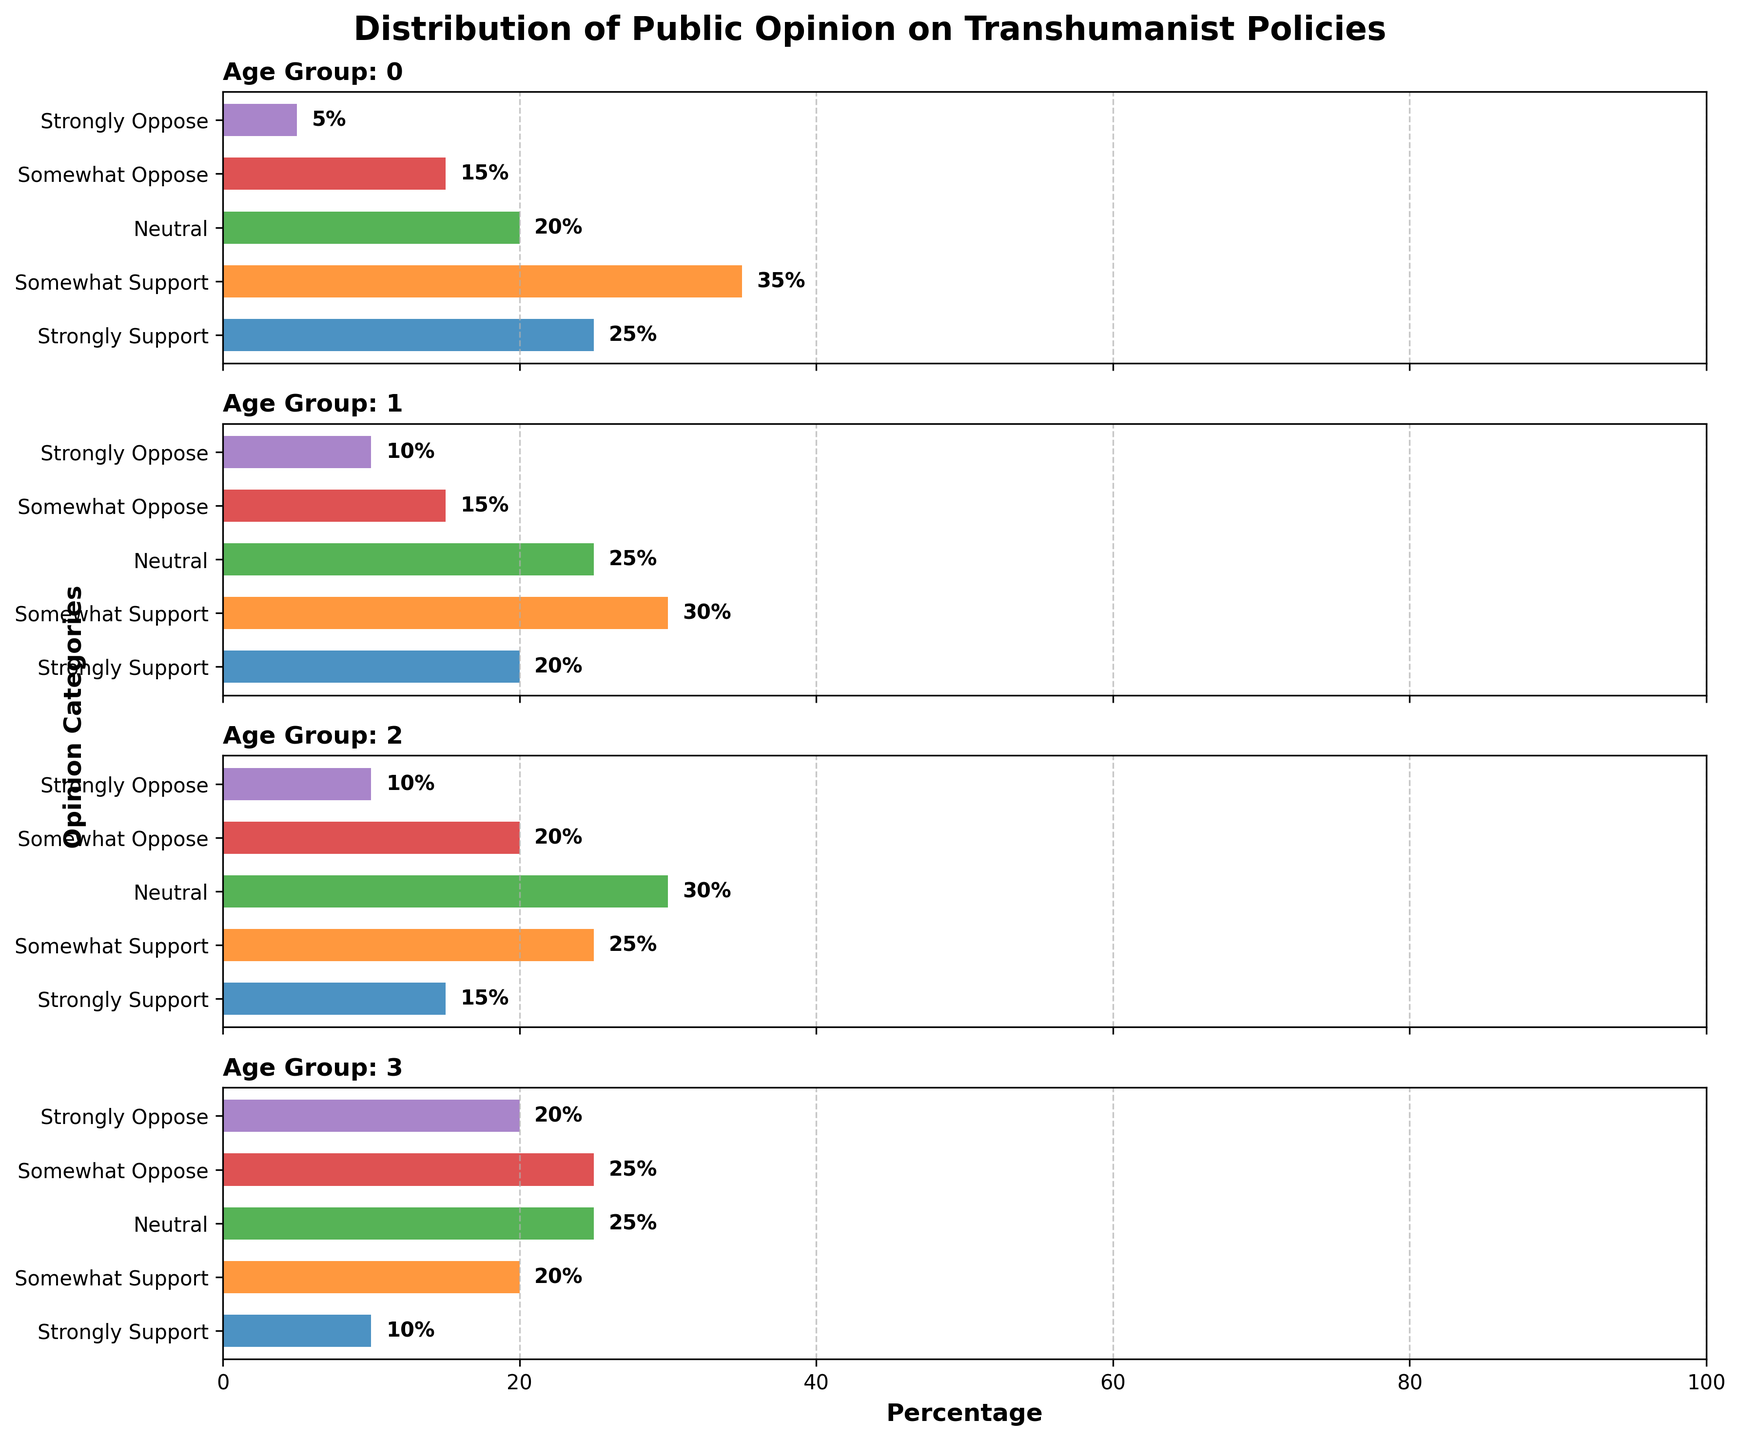What is the overall title of the figure? The title is displayed at the top of the figure and should be clear and readable.
Answer: Distribution of Public Opinion on Transhumanist Policies Which age group has the highest percentage of "Strongly Support" for transhumanist policies? Observing the "Strongly Support" bars across all panels, the tallest bar belongs to the 18-29 age group.
Answer: 18-29 How does the "Neutral" opinion differ between the 18-29 and 60+ age groups? The "Neutral" category value for the 18-29 age group is 20%, while for the 60+ age group, it is 25%. Subtracting 20% from 25% gives a difference of 5%.
Answer: 5% Which age group shows the most opposition (both "Somewhat Oppose" and "Strongly Oppose" combined) to transhumanist policies? We need to add values of "Somewhat Oppose" and "Strongly Oppose" for each age group and compare. For 18-29: 15+5=20%. For 30-44: 15+10=25%. For 45-59: 20+10=30%. For 60+: 25+20=45%. The highest combined opposition is in the 60+ age group.
Answer: 60+ What is the combined percentage of all supportive opinions (both "Strongly Support" and "Somewhat Support" combined) for the 30-44 age group? Summing the "Strongly Support" and "Somewhat Support" categories for the 30-44 age group: 20% + 30% = 50%.
Answer: 50% Which age group has the most diverse (varied percentage across categories) public opinion on transhumanist policies? To determine the diversity, one must look at the spread of opinions within each age group. The 60+ age group shows a significant spread across different categories: 10%, 20%, 25%, 25%, and 20%. This spread is much more varied than in other age groups.
Answer: 60+ What percentage of the 45-59 age group strongly opposes transhumanist policies? Locate the "Strongly Oppose" bar for the 45-59 age group. This bar indicates 10%.
Answer: 10% Which age group has the least percentage of "Somewhat Support" opinion on transhumanist policies? The "Somewhat Support" bar is the shortest for the 60+ age group, showing only 20%.
Answer: 60+ Compare the "Strongly Support" percentages between the 18-29 and 30-44 age groups. Which group has a higher percentage and by how much? The "Strongly Support" percentage for the 18-29 age group is 25%, and for the 30-44 age group, it is 20%. The difference is 25% - 20% = 5%.
Answer: 18-29, 5% 